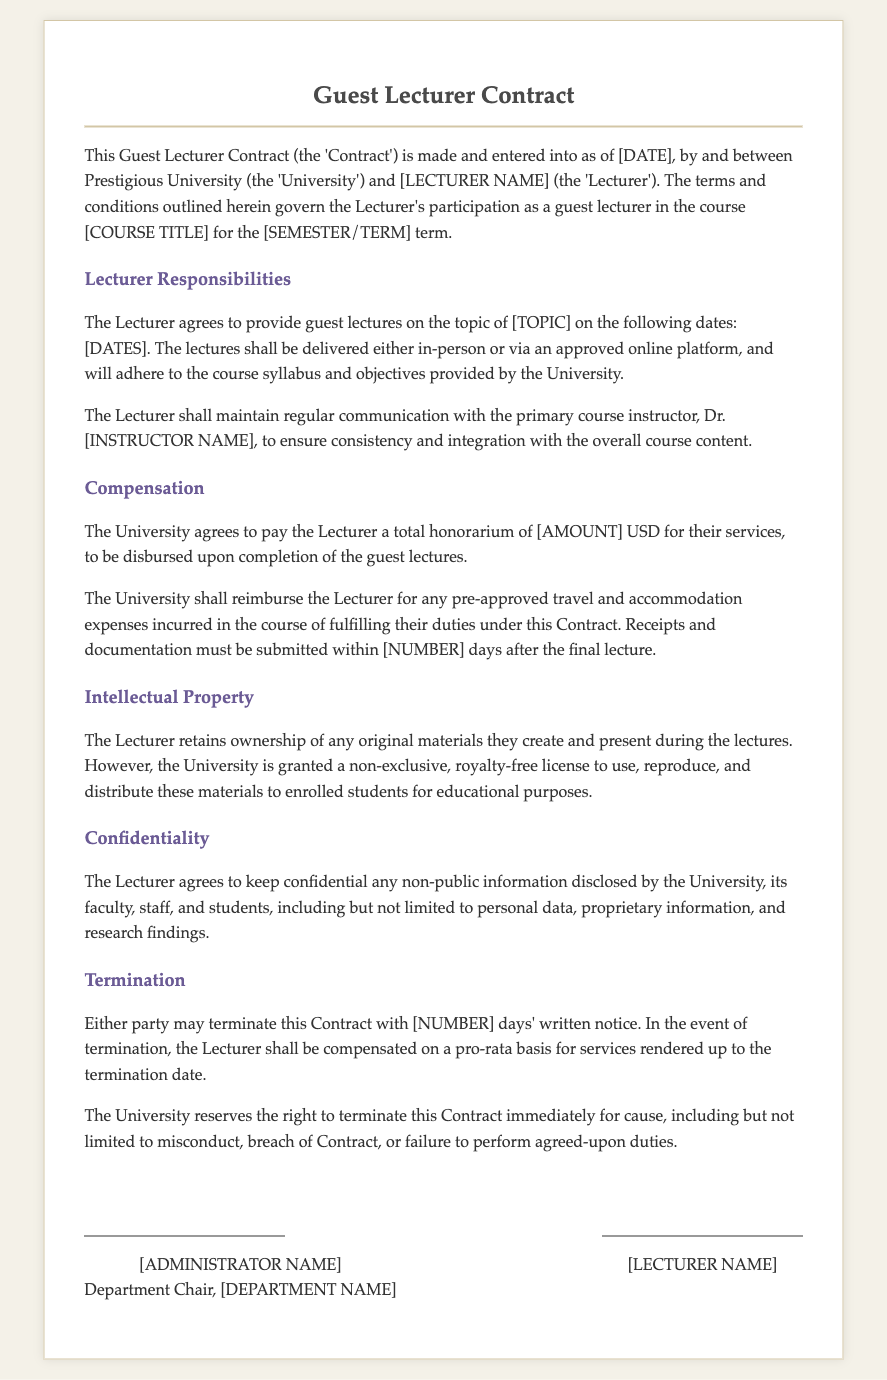What is the name of the university? The university is referred to as "Prestigious University" in the document.
Answer: Prestigious University Who is the primary course instructor? The primary course instructor's name is required as part of the contact and is indicated as "Dr. [INSTRUCTOR NAME]".
Answer: Dr. [INSTRUCTOR NAME] What is the total honorarium for the Lecturer? The compensation for the services is specified as "[AMOUNT] USD", which will need to be filled in based on agreement.
Answer: [AMOUNT] USD How many days must receipts be submitted after the final lecture? The exact number of days for submitting receipts is indicated as "[NUMBER] days" in the document.
Answer: [NUMBER] days What rights does the University have over the materials created by the Lecturer? The contract grants the University a "non-exclusive, royalty-free license" to use the materials.
Answer: non-exclusive, royalty-free license What is the notice period for terminating the contract? The document specifies that either party may terminate the contract with "[NUMBER] days' written notice".
Answer: [NUMBER] days What must the Lecturer do before receiving reimbursement for expenses? The Lecturer must submit "receipts and documentation" within the specified time frame.
Answer: receipts and documentation What consequences does the University have for misconduct? The University reserves the right to terminate the contract "immediately for cause" based on misconduct.
Answer: immediately for cause What type of materials does the Lecturer retain ownership of? The Lecturer retains ownership of "any original materials" they create and present during lectures.
Answer: any original materials 